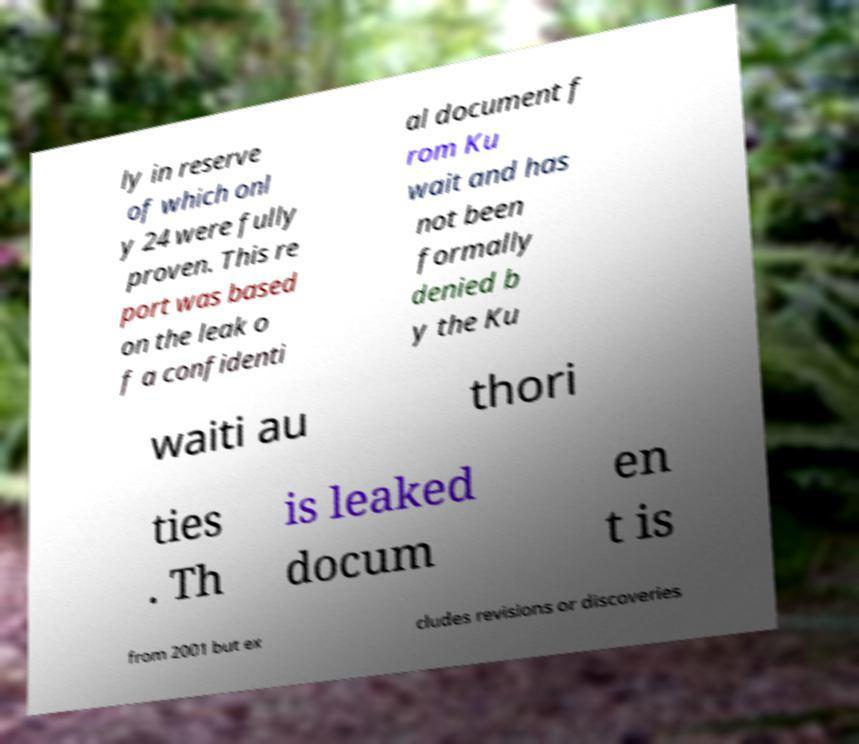Please read and relay the text visible in this image. What does it say? ly in reserve of which onl y 24 were fully proven. This re port was based on the leak o f a confidenti al document f rom Ku wait and has not been formally denied b y the Ku waiti au thori ties . Th is leaked docum en t is from 2001 but ex cludes revisions or discoveries 